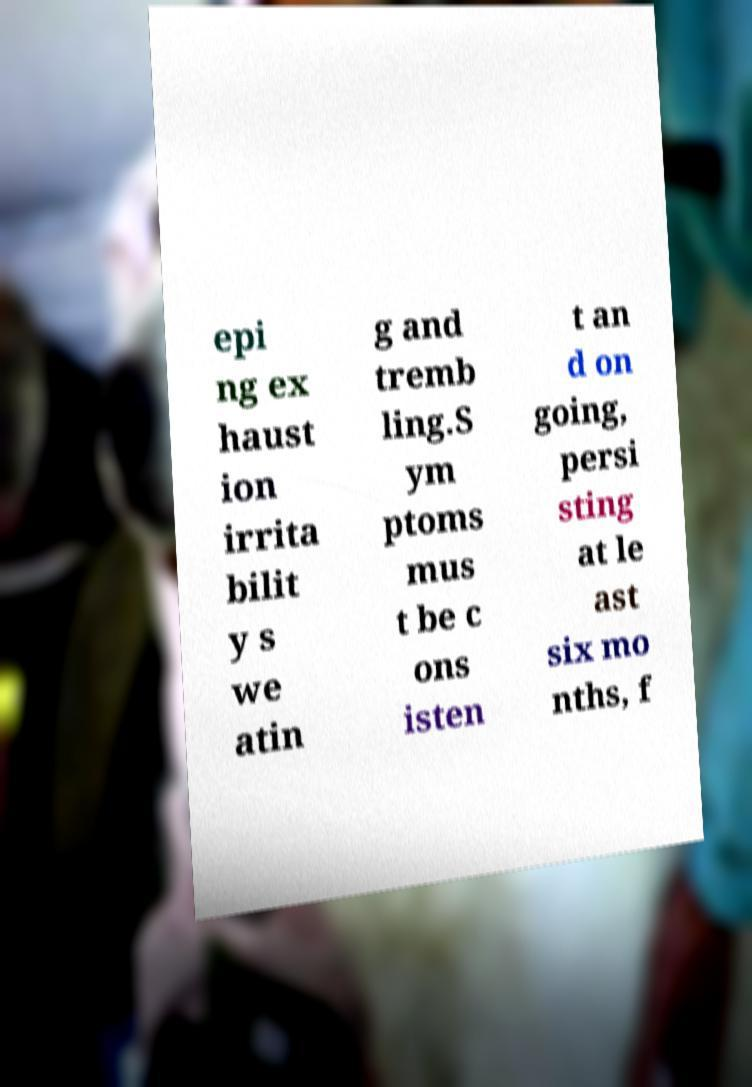For documentation purposes, I need the text within this image transcribed. Could you provide that? epi ng ex haust ion irrita bilit y s we atin g and tremb ling.S ym ptoms mus t be c ons isten t an d on going, persi sting at le ast six mo nths, f 